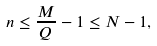<formula> <loc_0><loc_0><loc_500><loc_500>n \leq \frac { M } { Q } - 1 \leq N - 1 ,</formula> 